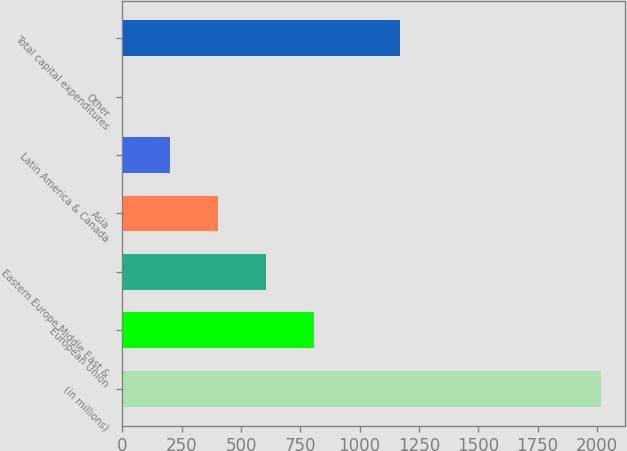Convert chart. <chart><loc_0><loc_0><loc_500><loc_500><bar_chart><fcel>(in millions)<fcel>European Union<fcel>Eastern Europe Middle East &<fcel>Asia<fcel>Latin America & Canada<fcel>Other<fcel>Total capital expenditures<nl><fcel>2016<fcel>807<fcel>605.5<fcel>404<fcel>202.5<fcel>1<fcel>1172<nl></chart> 